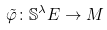Convert formula to latex. <formula><loc_0><loc_0><loc_500><loc_500>\tilde { \varphi } \colon \mathbb { S } ^ { \lambda } E \rightarrow M</formula> 